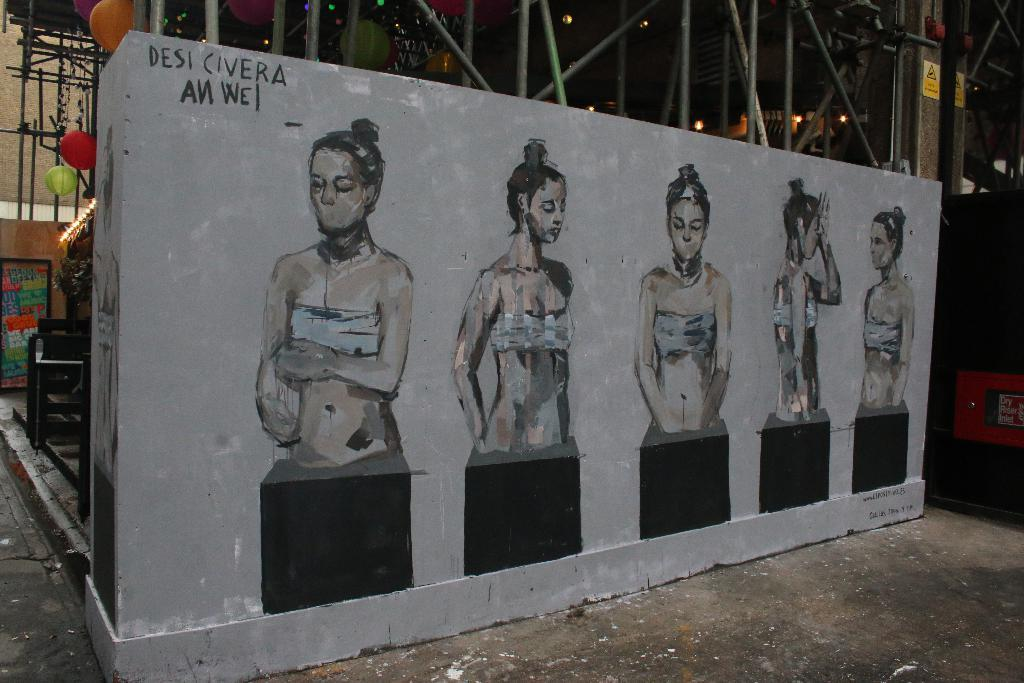What type of artwork is depicted in the image? There are paintings of women in the image. What can be seen on the wall in the image? There is text on the wall in the image. What type of lighting is visible in the image? There are lights visible in the image. What is visible in the background of the image? There is a road, sign boards, and colorful objects in the background of the image. What type of zephyr can be heard in the image? There is no zephyr present in the image, as it is a visual medium and does not include sound. How do the sign boards turn in the image? The sign boards do not turn in the image; they are stationary. 